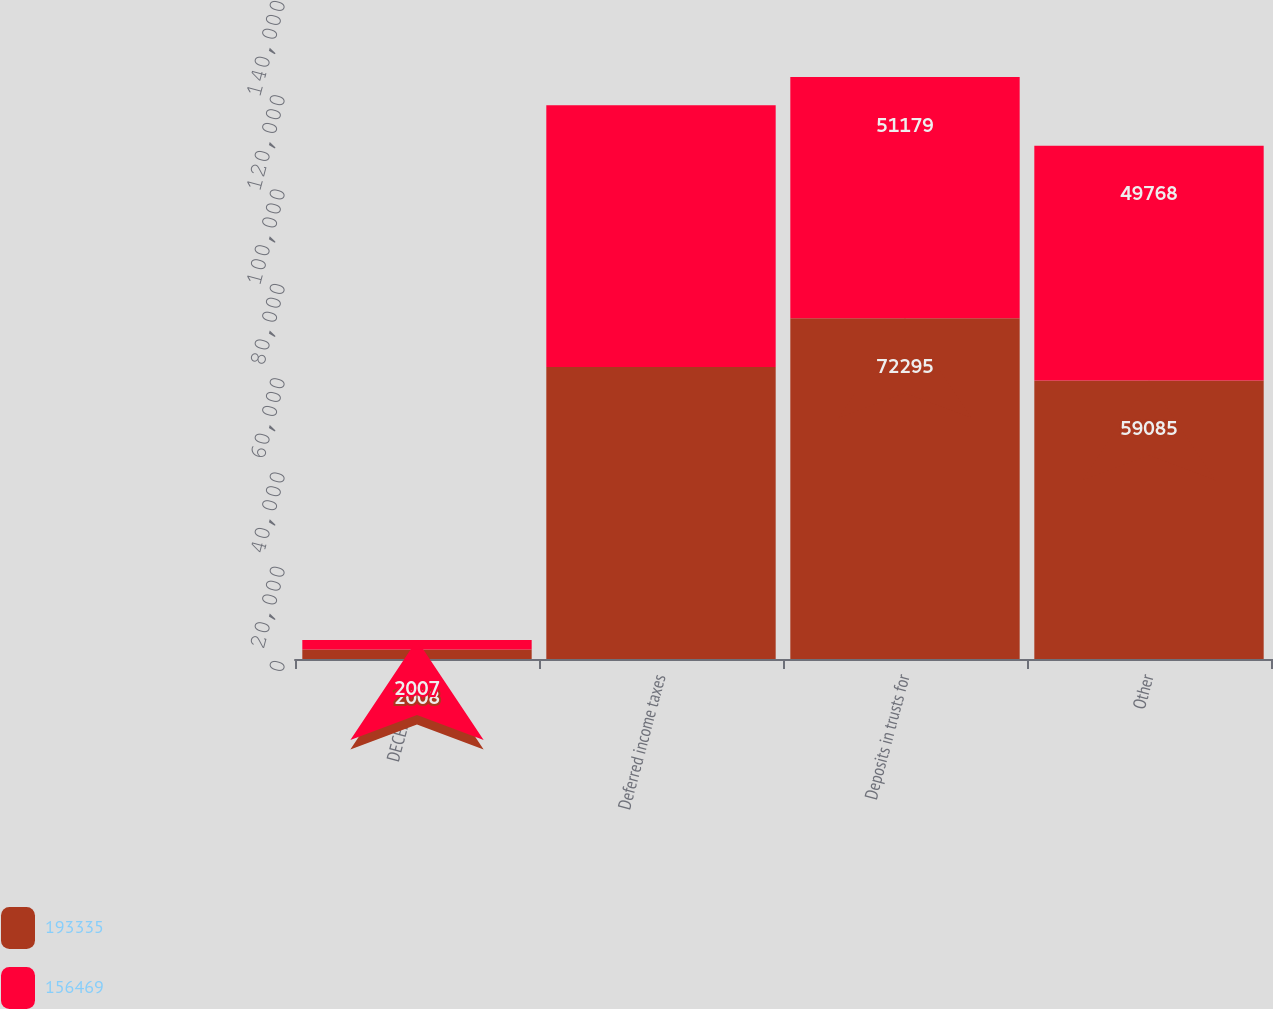Convert chart. <chart><loc_0><loc_0><loc_500><loc_500><stacked_bar_chart><ecel><fcel>DECEMBER 31<fcel>Deferred income taxes<fcel>Deposits in trusts for<fcel>Other<nl><fcel>193335<fcel>2008<fcel>61955<fcel>72295<fcel>59085<nl><fcel>156469<fcel>2007<fcel>55522<fcel>51179<fcel>49768<nl></chart> 